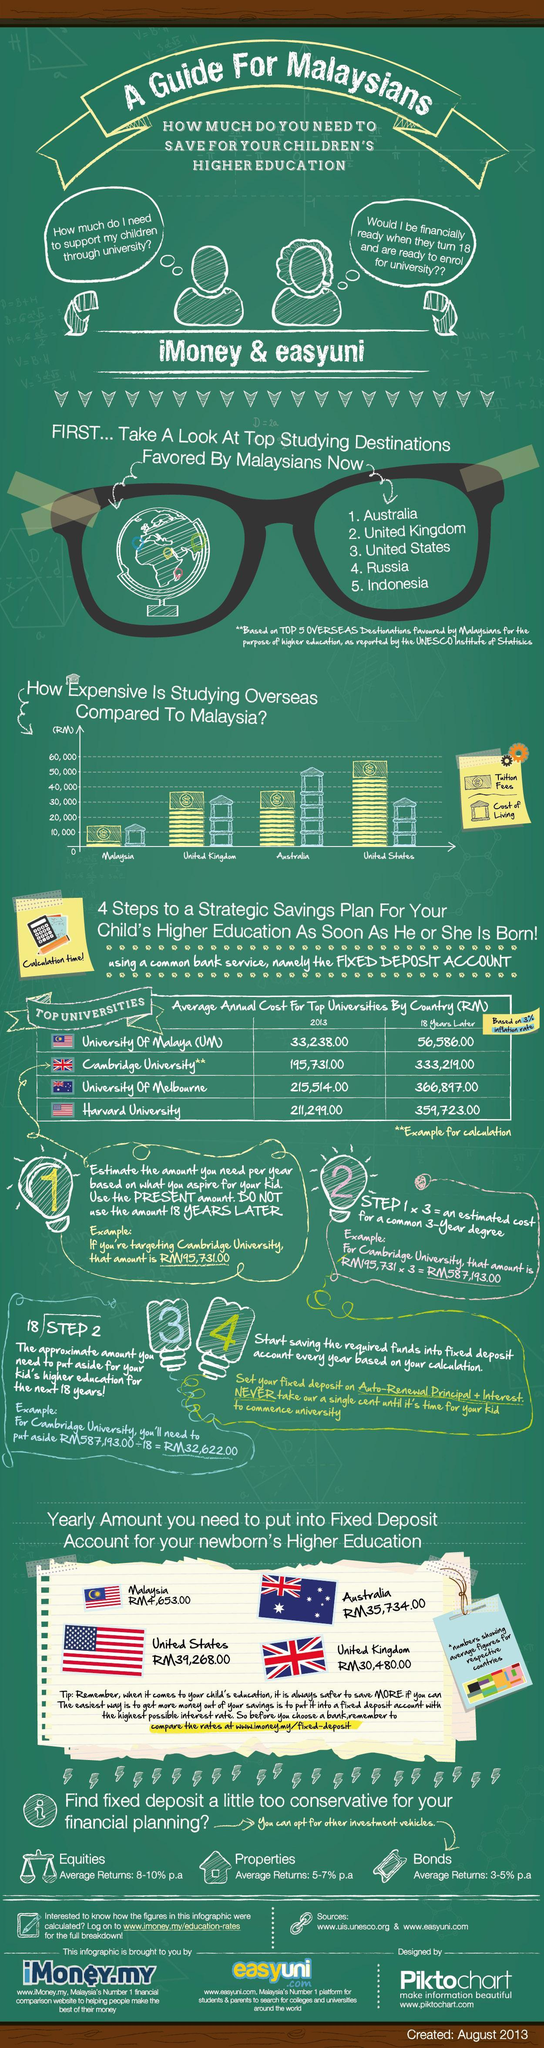What is the yearly amount to put into a fixed deposit account for the newborn's higher education in Malaysia?
Answer the question with a short phrase. RM4,653.00 What is the yearly amount to put into a fixed deposit account for the newborn's higher education in the United States? RM39,268.00 What is the difference between the average annual cost at Cambridge university 18 years later and 2013? 137488 What is the difference between the average annual cost at the University of Malaysia 18 years later and 2013? 23348 Which university has the highest average annual cost after 18 years? University of Malaysia (UM) What is the difference between the average annual cost at the University of Melbourne 18 years later and 2013? 151383 Which university has the second-lowest average annual cost after 18 years? Harvard University What is the difference between the average annual cost at Harvard University 18 years later and 2013? 148424 What is the yearly amount to put into a fixed deposit account for the newborn's higher education in Australia? RM35,734.00 What is the yearly amount to put into a fixed deposit account for the newborn's higher education in the United Kingdom? RM30,480.00 